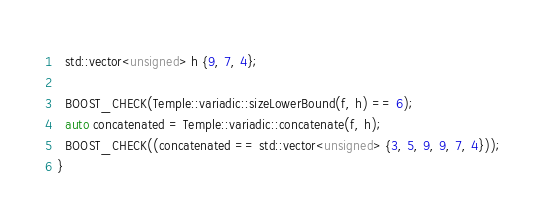Convert code to text. <code><loc_0><loc_0><loc_500><loc_500><_C++_>  std::vector<unsigned> h {9, 7, 4};

  BOOST_CHECK(Temple::variadic::sizeLowerBound(f, h) == 6);
  auto concatenated = Temple::variadic::concatenate(f, h);
  BOOST_CHECK((concatenated == std::vector<unsigned> {3, 5, 9, 9, 7, 4}));
}
</code> 